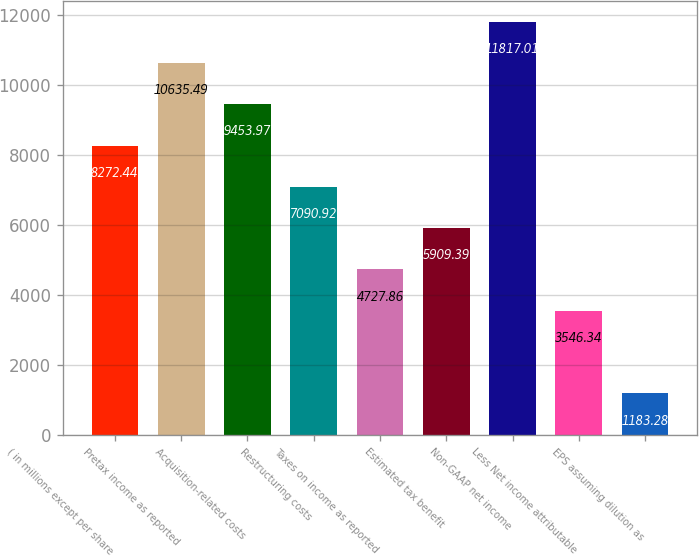<chart> <loc_0><loc_0><loc_500><loc_500><bar_chart><fcel>( in millions except per share<fcel>Pretax income as reported<fcel>Acquisition-related costs<fcel>Restructuring costs<fcel>Taxes on income as reported<fcel>Estimated tax benefit<fcel>Non-GAAP net income<fcel>Less Net income attributable<fcel>EPS assuming dilution as<nl><fcel>8272.44<fcel>10635.5<fcel>9453.97<fcel>7090.92<fcel>4727.86<fcel>5909.39<fcel>11817<fcel>3546.34<fcel>1183.28<nl></chart> 